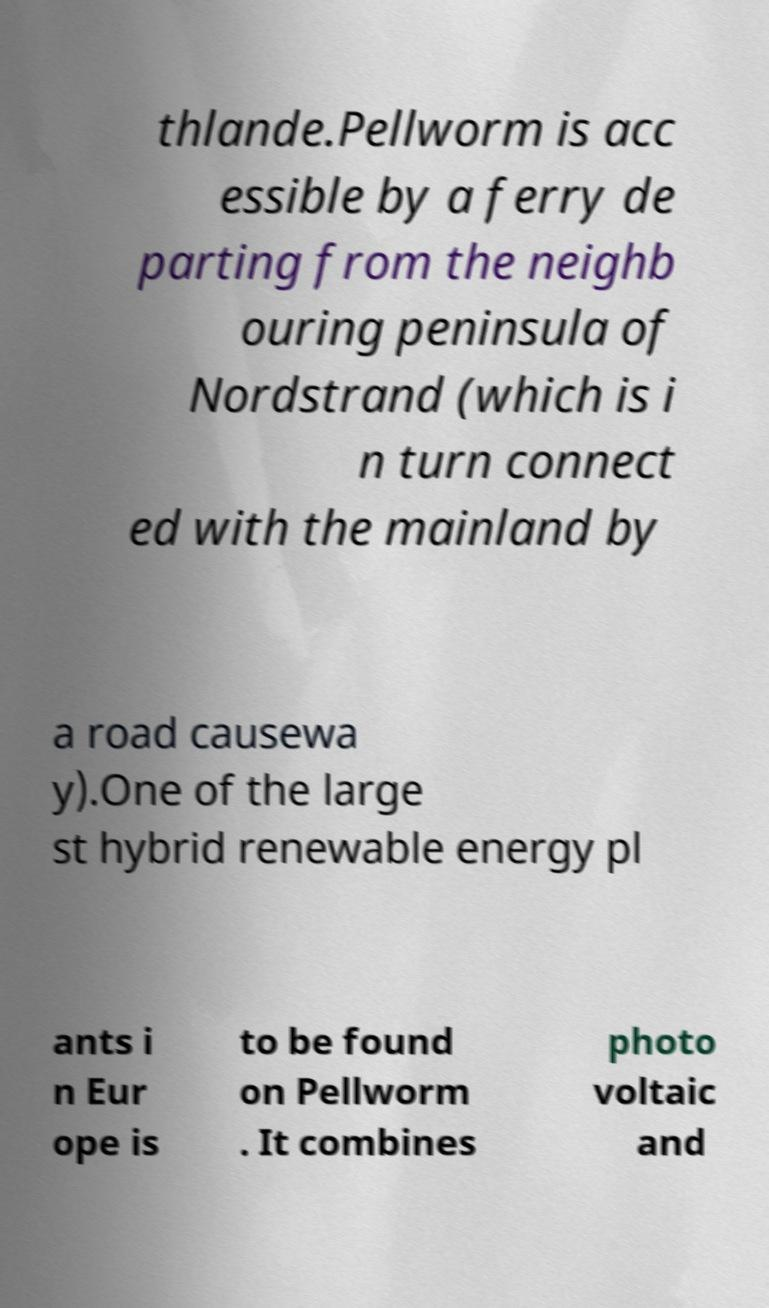I need the written content from this picture converted into text. Can you do that? thlande.Pellworm is acc essible by a ferry de parting from the neighb ouring peninsula of Nordstrand (which is i n turn connect ed with the mainland by a road causewa y).One of the large st hybrid renewable energy pl ants i n Eur ope is to be found on Pellworm . It combines photo voltaic and 